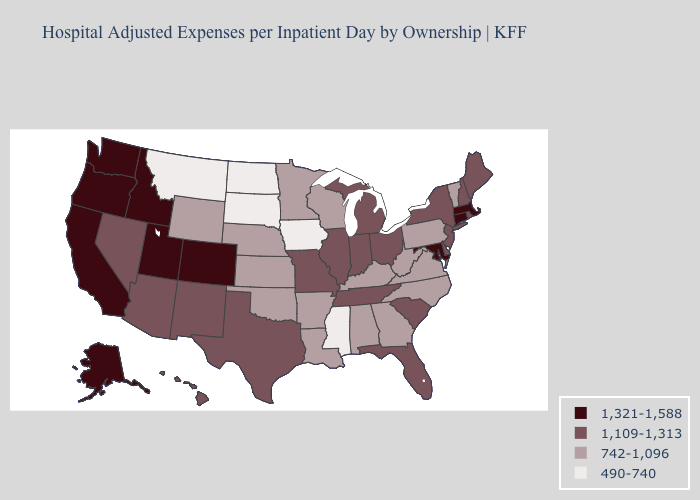What is the value of Indiana?
Short answer required. 1,109-1,313. Does Minnesota have the highest value in the MidWest?
Quick response, please. No. Name the states that have a value in the range 1,109-1,313?
Concise answer only. Arizona, Delaware, Florida, Hawaii, Illinois, Indiana, Maine, Michigan, Missouri, Nevada, New Hampshire, New Jersey, New Mexico, New York, Ohio, Rhode Island, South Carolina, Tennessee, Texas. What is the value of Oregon?
Quick response, please. 1,321-1,588. What is the value of Kentucky?
Give a very brief answer. 742-1,096. What is the value of Kansas?
Quick response, please. 742-1,096. Which states have the lowest value in the USA?
Be succinct. Iowa, Mississippi, Montana, North Dakota, South Dakota. What is the highest value in the MidWest ?
Short answer required. 1,109-1,313. Does North Dakota have a lower value than New Mexico?
Concise answer only. Yes. What is the highest value in states that border North Carolina?
Keep it brief. 1,109-1,313. What is the value of Pennsylvania?
Write a very short answer. 742-1,096. What is the lowest value in the USA?
Be succinct. 490-740. Does Arizona have the lowest value in the West?
Short answer required. No. Does Massachusetts have the highest value in the Northeast?
Give a very brief answer. Yes. 